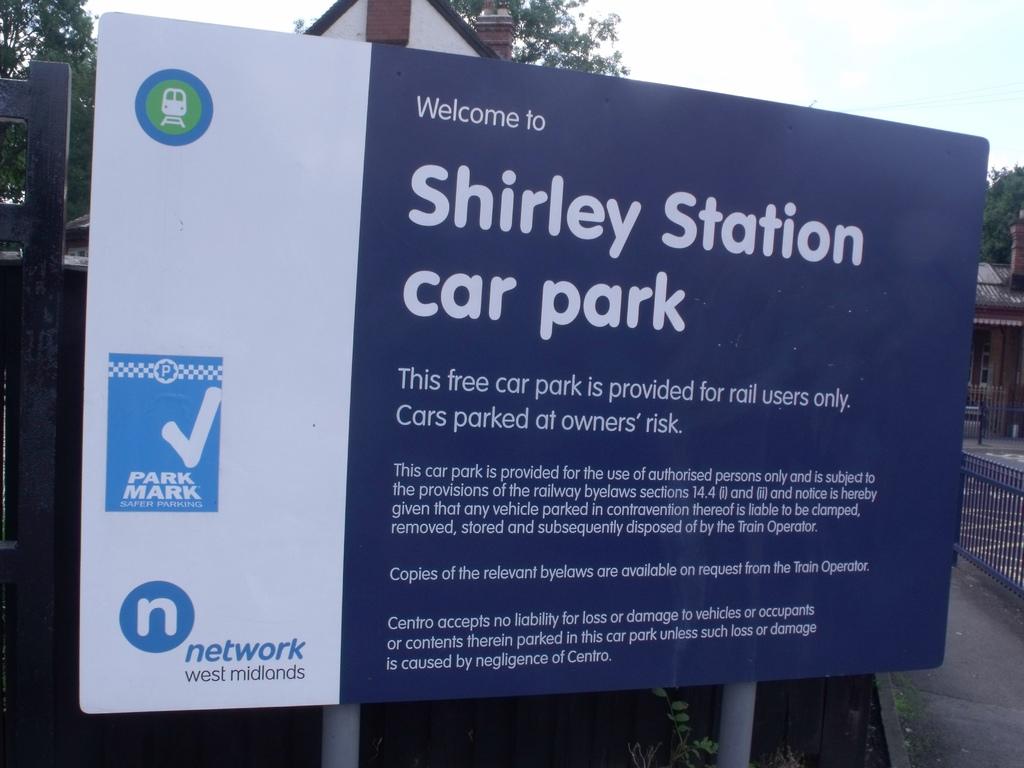How much does it cost to use this car park?
Your response must be concise. Free. 